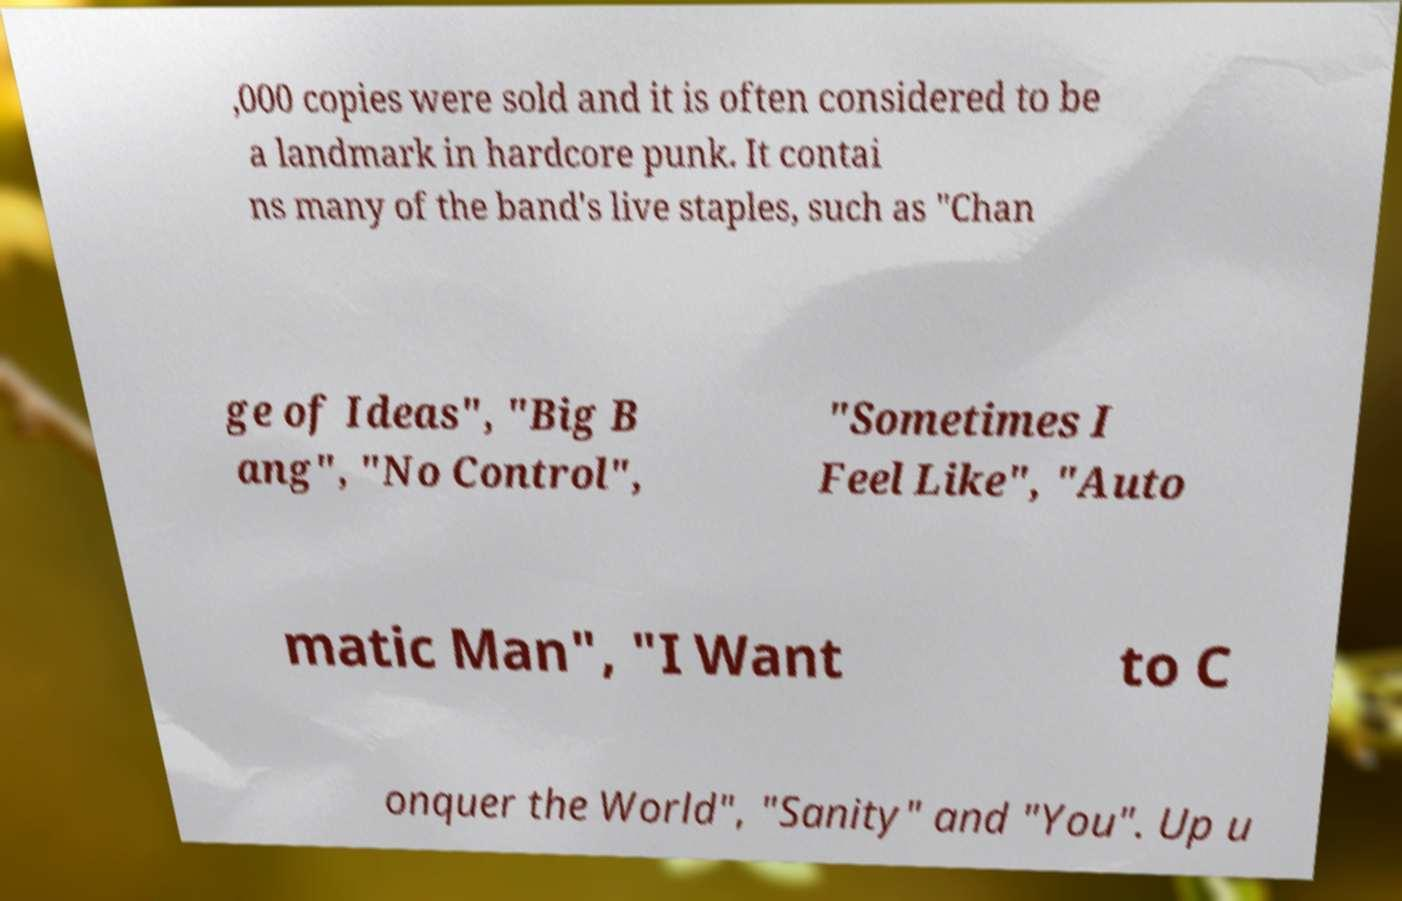Please identify and transcribe the text found in this image. ,000 copies were sold and it is often considered to be a landmark in hardcore punk. It contai ns many of the band's live staples, such as "Chan ge of Ideas", "Big B ang", "No Control", "Sometimes I Feel Like", "Auto matic Man", "I Want to C onquer the World", "Sanity" and "You". Up u 